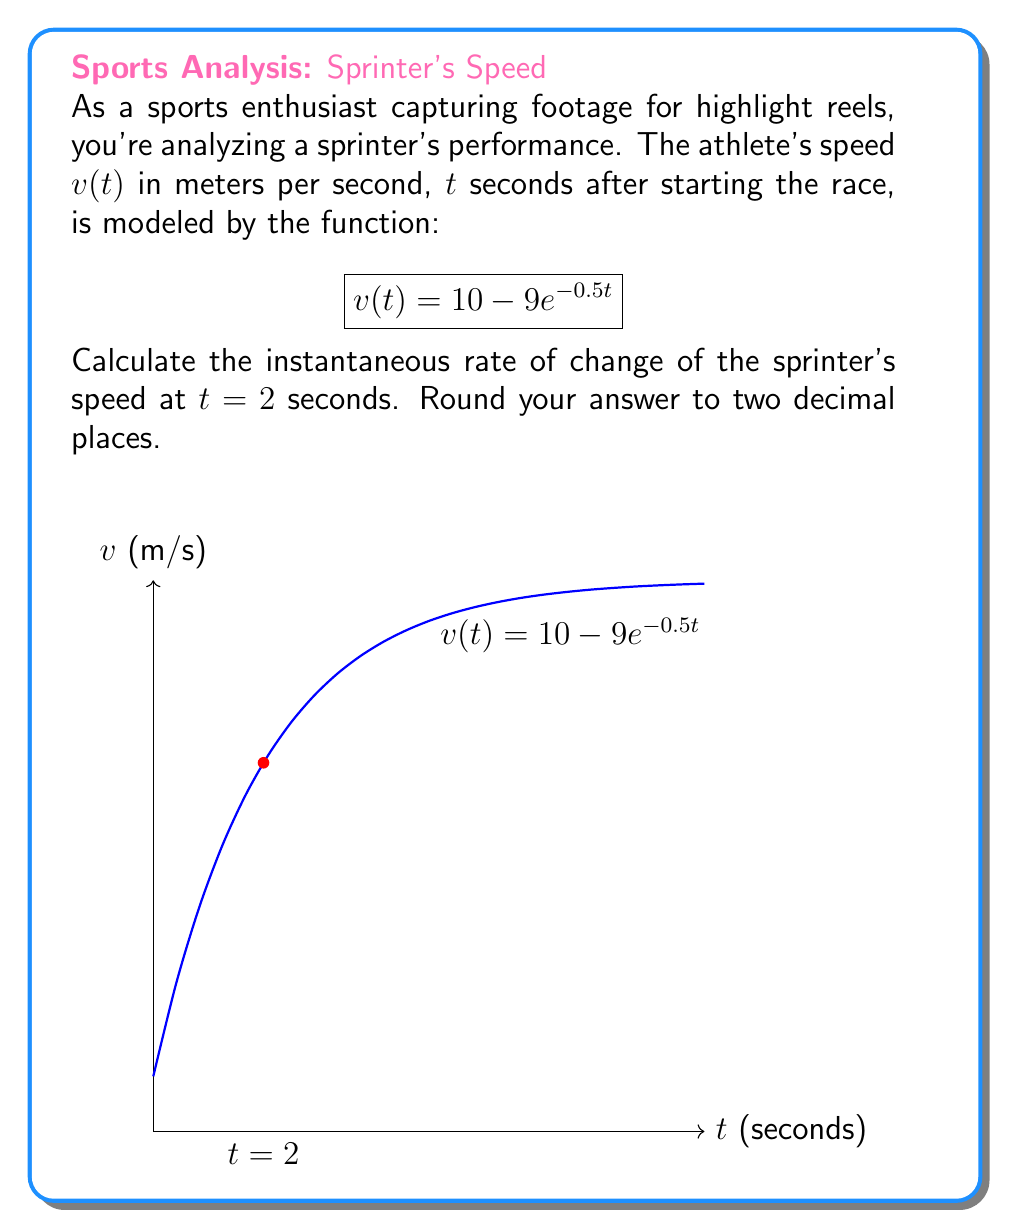Solve this math problem. To find the instantaneous rate of change of the sprinter's speed at $t = 2$ seconds, we need to calculate the derivative of $v(t)$ and evaluate it at $t = 2$.

1) First, let's find the derivative of $v(t)$:
   $$v(t) = 10 - 9e^{-0.5t}$$
   $$v'(t) = -9 \cdot (-0.5)e^{-0.5t} = 4.5e^{-0.5t}$$

2) Now, we evaluate $v'(t)$ at $t = 2$:
   $$v'(2) = 4.5e^{-0.5(2)} = 4.5e^{-1}$$

3) Calculate the value:
   $$4.5e^{-1} \approx 4.5 \cdot 0.3679 \approx 1.6555$$

4) Rounding to two decimal places:
   $$1.66 \text{ m/s}^2$$

Therefore, the instantaneous rate of change of the sprinter's speed at $t = 2$ seconds is approximately 1.66 m/s².
Answer: 1.66 m/s² 